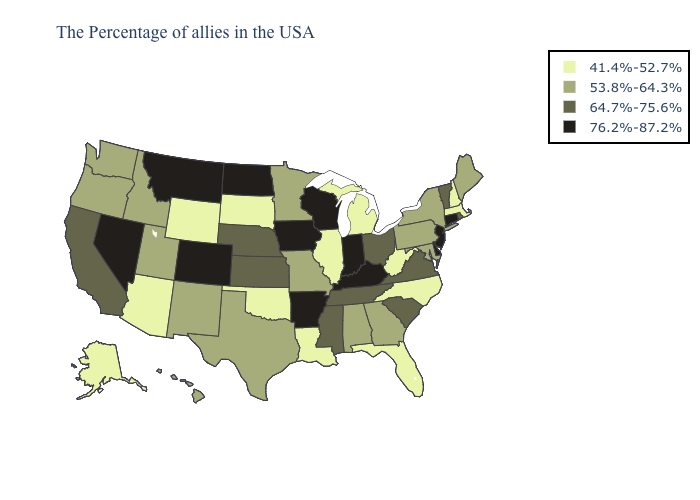What is the lowest value in states that border Georgia?
Give a very brief answer. 41.4%-52.7%. Which states have the lowest value in the USA?
Short answer required. Massachusetts, New Hampshire, North Carolina, West Virginia, Florida, Michigan, Illinois, Louisiana, Oklahoma, South Dakota, Wyoming, Arizona, Alaska. Does the first symbol in the legend represent the smallest category?
Be succinct. Yes. Does Idaho have the same value as Utah?
Keep it brief. Yes. What is the value of Georgia?
Be succinct. 53.8%-64.3%. Does the map have missing data?
Keep it brief. No. Name the states that have a value in the range 64.7%-75.6%?
Short answer required. Rhode Island, Vermont, Virginia, South Carolina, Ohio, Tennessee, Mississippi, Kansas, Nebraska, California. Name the states that have a value in the range 76.2%-87.2%?
Concise answer only. Connecticut, New Jersey, Delaware, Kentucky, Indiana, Wisconsin, Arkansas, Iowa, North Dakota, Colorado, Montana, Nevada. What is the value of West Virginia?
Write a very short answer. 41.4%-52.7%. Among the states that border Vermont , does New York have the highest value?
Write a very short answer. Yes. Name the states that have a value in the range 76.2%-87.2%?
Concise answer only. Connecticut, New Jersey, Delaware, Kentucky, Indiana, Wisconsin, Arkansas, Iowa, North Dakota, Colorado, Montana, Nevada. Does Wisconsin have the highest value in the MidWest?
Give a very brief answer. Yes. What is the value of South Carolina?
Concise answer only. 64.7%-75.6%. What is the highest value in states that border Maryland?
Answer briefly. 76.2%-87.2%. Does Iowa have the highest value in the MidWest?
Write a very short answer. Yes. 